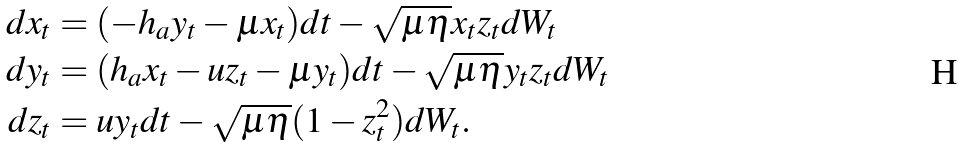<formula> <loc_0><loc_0><loc_500><loc_500>d x _ { t } & = ( - h _ { a } y _ { t } - \mu x _ { t } ) d t - \sqrt { \mu \eta } x _ { t } z _ { t } d W _ { t } \\ d y _ { t } & = ( h _ { a } x _ { t } - u z _ { t } - \mu y _ { t } ) d t - \sqrt { \mu \eta } y _ { t } z _ { t } d W _ { t } \\ d z _ { t } & = u y _ { t } d t - \sqrt { \mu \eta } ( 1 - z _ { t } ^ { 2 } ) d W _ { t } .</formula> 